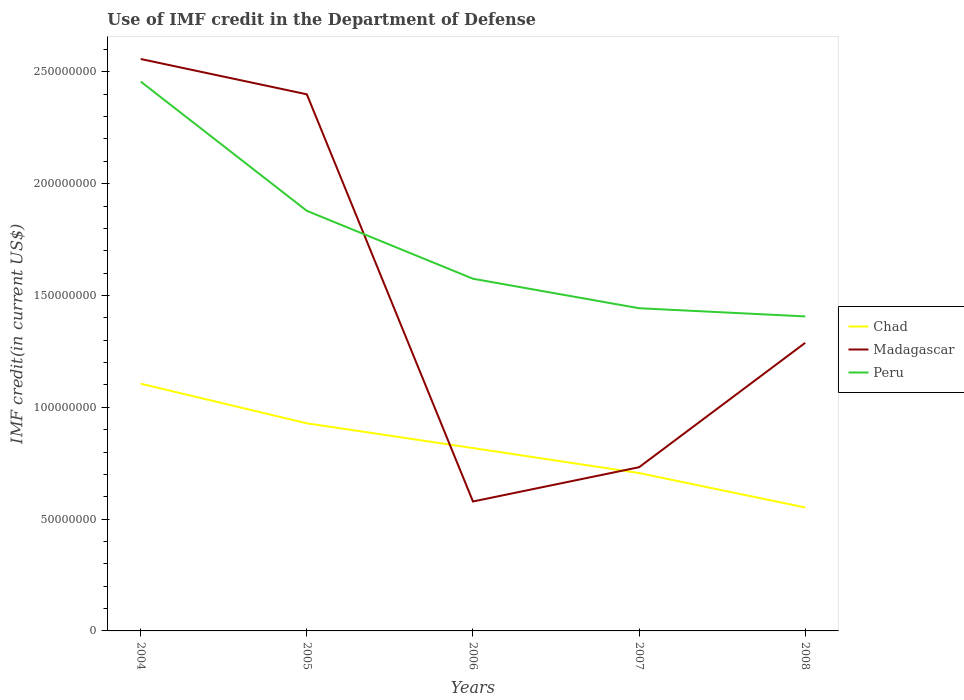How many different coloured lines are there?
Offer a terse response. 3. Does the line corresponding to Madagascar intersect with the line corresponding to Chad?
Give a very brief answer. Yes. Across all years, what is the maximum IMF credit in the Department of Defense in Peru?
Give a very brief answer. 1.41e+08. In which year was the IMF credit in the Department of Defense in Peru maximum?
Provide a succinct answer. 2008. What is the total IMF credit in the Department of Defense in Peru in the graph?
Provide a succinct answer. 1.68e+07. What is the difference between the highest and the second highest IMF credit in the Department of Defense in Peru?
Offer a terse response. 1.05e+08. What is the difference between the highest and the lowest IMF credit in the Department of Defense in Chad?
Offer a terse response. 2. How many lines are there?
Your answer should be very brief. 3. What is the difference between two consecutive major ticks on the Y-axis?
Provide a short and direct response. 5.00e+07. Are the values on the major ticks of Y-axis written in scientific E-notation?
Give a very brief answer. No. Does the graph contain any zero values?
Your answer should be very brief. No. How many legend labels are there?
Your answer should be very brief. 3. What is the title of the graph?
Your answer should be compact. Use of IMF credit in the Department of Defense. What is the label or title of the X-axis?
Give a very brief answer. Years. What is the label or title of the Y-axis?
Your answer should be very brief. IMF credit(in current US$). What is the IMF credit(in current US$) in Chad in 2004?
Your response must be concise. 1.11e+08. What is the IMF credit(in current US$) in Madagascar in 2004?
Keep it short and to the point. 2.56e+08. What is the IMF credit(in current US$) of Peru in 2004?
Offer a terse response. 2.46e+08. What is the IMF credit(in current US$) in Chad in 2005?
Give a very brief answer. 9.28e+07. What is the IMF credit(in current US$) in Madagascar in 2005?
Offer a very short reply. 2.40e+08. What is the IMF credit(in current US$) in Peru in 2005?
Make the answer very short. 1.88e+08. What is the IMF credit(in current US$) in Chad in 2006?
Your answer should be compact. 8.18e+07. What is the IMF credit(in current US$) in Madagascar in 2006?
Offer a very short reply. 5.79e+07. What is the IMF credit(in current US$) in Peru in 2006?
Offer a terse response. 1.58e+08. What is the IMF credit(in current US$) of Chad in 2007?
Your response must be concise. 7.06e+07. What is the IMF credit(in current US$) of Madagascar in 2007?
Provide a succinct answer. 7.32e+07. What is the IMF credit(in current US$) in Peru in 2007?
Keep it short and to the point. 1.44e+08. What is the IMF credit(in current US$) of Chad in 2008?
Make the answer very short. 5.52e+07. What is the IMF credit(in current US$) in Madagascar in 2008?
Offer a terse response. 1.29e+08. What is the IMF credit(in current US$) of Peru in 2008?
Provide a short and direct response. 1.41e+08. Across all years, what is the maximum IMF credit(in current US$) in Chad?
Give a very brief answer. 1.11e+08. Across all years, what is the maximum IMF credit(in current US$) in Madagascar?
Your answer should be very brief. 2.56e+08. Across all years, what is the maximum IMF credit(in current US$) in Peru?
Offer a very short reply. 2.46e+08. Across all years, what is the minimum IMF credit(in current US$) in Chad?
Give a very brief answer. 5.52e+07. Across all years, what is the minimum IMF credit(in current US$) in Madagascar?
Provide a succinct answer. 5.79e+07. Across all years, what is the minimum IMF credit(in current US$) in Peru?
Keep it short and to the point. 1.41e+08. What is the total IMF credit(in current US$) in Chad in the graph?
Provide a succinct answer. 4.11e+08. What is the total IMF credit(in current US$) in Madagascar in the graph?
Your answer should be very brief. 7.56e+08. What is the total IMF credit(in current US$) of Peru in the graph?
Provide a short and direct response. 8.76e+08. What is the difference between the IMF credit(in current US$) in Chad in 2004 and that in 2005?
Ensure brevity in your answer.  1.77e+07. What is the difference between the IMF credit(in current US$) of Madagascar in 2004 and that in 2005?
Offer a terse response. 1.58e+07. What is the difference between the IMF credit(in current US$) of Peru in 2004 and that in 2005?
Provide a succinct answer. 5.78e+07. What is the difference between the IMF credit(in current US$) in Chad in 2004 and that in 2006?
Provide a short and direct response. 2.88e+07. What is the difference between the IMF credit(in current US$) in Madagascar in 2004 and that in 2006?
Provide a succinct answer. 1.98e+08. What is the difference between the IMF credit(in current US$) in Peru in 2004 and that in 2006?
Provide a short and direct response. 8.82e+07. What is the difference between the IMF credit(in current US$) in Chad in 2004 and that in 2007?
Provide a short and direct response. 4.00e+07. What is the difference between the IMF credit(in current US$) in Madagascar in 2004 and that in 2007?
Provide a succinct answer. 1.83e+08. What is the difference between the IMF credit(in current US$) in Peru in 2004 and that in 2007?
Provide a succinct answer. 1.01e+08. What is the difference between the IMF credit(in current US$) of Chad in 2004 and that in 2008?
Your response must be concise. 5.54e+07. What is the difference between the IMF credit(in current US$) of Madagascar in 2004 and that in 2008?
Offer a very short reply. 1.27e+08. What is the difference between the IMF credit(in current US$) of Peru in 2004 and that in 2008?
Your answer should be very brief. 1.05e+08. What is the difference between the IMF credit(in current US$) of Chad in 2005 and that in 2006?
Provide a short and direct response. 1.11e+07. What is the difference between the IMF credit(in current US$) in Madagascar in 2005 and that in 2006?
Offer a very short reply. 1.82e+08. What is the difference between the IMF credit(in current US$) in Peru in 2005 and that in 2006?
Your answer should be compact. 3.04e+07. What is the difference between the IMF credit(in current US$) of Chad in 2005 and that in 2007?
Give a very brief answer. 2.22e+07. What is the difference between the IMF credit(in current US$) in Madagascar in 2005 and that in 2007?
Offer a terse response. 1.67e+08. What is the difference between the IMF credit(in current US$) in Peru in 2005 and that in 2007?
Give a very brief answer. 4.36e+07. What is the difference between the IMF credit(in current US$) of Chad in 2005 and that in 2008?
Offer a terse response. 3.76e+07. What is the difference between the IMF credit(in current US$) of Madagascar in 2005 and that in 2008?
Provide a succinct answer. 1.11e+08. What is the difference between the IMF credit(in current US$) in Peru in 2005 and that in 2008?
Keep it short and to the point. 4.72e+07. What is the difference between the IMF credit(in current US$) in Chad in 2006 and that in 2007?
Give a very brief answer. 1.12e+07. What is the difference between the IMF credit(in current US$) of Madagascar in 2006 and that in 2007?
Your response must be concise. -1.53e+07. What is the difference between the IMF credit(in current US$) of Peru in 2006 and that in 2007?
Provide a succinct answer. 1.32e+07. What is the difference between the IMF credit(in current US$) of Chad in 2006 and that in 2008?
Offer a very short reply. 2.66e+07. What is the difference between the IMF credit(in current US$) in Madagascar in 2006 and that in 2008?
Provide a short and direct response. -7.10e+07. What is the difference between the IMF credit(in current US$) in Peru in 2006 and that in 2008?
Offer a terse response. 1.68e+07. What is the difference between the IMF credit(in current US$) in Chad in 2007 and that in 2008?
Make the answer very short. 1.54e+07. What is the difference between the IMF credit(in current US$) in Madagascar in 2007 and that in 2008?
Ensure brevity in your answer.  -5.56e+07. What is the difference between the IMF credit(in current US$) in Peru in 2007 and that in 2008?
Make the answer very short. 3.65e+06. What is the difference between the IMF credit(in current US$) in Chad in 2004 and the IMF credit(in current US$) in Madagascar in 2005?
Your response must be concise. -1.29e+08. What is the difference between the IMF credit(in current US$) of Chad in 2004 and the IMF credit(in current US$) of Peru in 2005?
Provide a succinct answer. -7.73e+07. What is the difference between the IMF credit(in current US$) of Madagascar in 2004 and the IMF credit(in current US$) of Peru in 2005?
Ensure brevity in your answer.  6.79e+07. What is the difference between the IMF credit(in current US$) in Chad in 2004 and the IMF credit(in current US$) in Madagascar in 2006?
Keep it short and to the point. 5.27e+07. What is the difference between the IMF credit(in current US$) in Chad in 2004 and the IMF credit(in current US$) in Peru in 2006?
Provide a succinct answer. -4.69e+07. What is the difference between the IMF credit(in current US$) in Madagascar in 2004 and the IMF credit(in current US$) in Peru in 2006?
Provide a succinct answer. 9.83e+07. What is the difference between the IMF credit(in current US$) in Chad in 2004 and the IMF credit(in current US$) in Madagascar in 2007?
Your answer should be very brief. 3.73e+07. What is the difference between the IMF credit(in current US$) in Chad in 2004 and the IMF credit(in current US$) in Peru in 2007?
Your answer should be compact. -3.38e+07. What is the difference between the IMF credit(in current US$) of Madagascar in 2004 and the IMF credit(in current US$) of Peru in 2007?
Keep it short and to the point. 1.11e+08. What is the difference between the IMF credit(in current US$) in Chad in 2004 and the IMF credit(in current US$) in Madagascar in 2008?
Your response must be concise. -1.83e+07. What is the difference between the IMF credit(in current US$) in Chad in 2004 and the IMF credit(in current US$) in Peru in 2008?
Your response must be concise. -3.01e+07. What is the difference between the IMF credit(in current US$) of Madagascar in 2004 and the IMF credit(in current US$) of Peru in 2008?
Keep it short and to the point. 1.15e+08. What is the difference between the IMF credit(in current US$) in Chad in 2005 and the IMF credit(in current US$) in Madagascar in 2006?
Your answer should be compact. 3.50e+07. What is the difference between the IMF credit(in current US$) in Chad in 2005 and the IMF credit(in current US$) in Peru in 2006?
Your answer should be compact. -6.47e+07. What is the difference between the IMF credit(in current US$) in Madagascar in 2005 and the IMF credit(in current US$) in Peru in 2006?
Make the answer very short. 8.25e+07. What is the difference between the IMF credit(in current US$) of Chad in 2005 and the IMF credit(in current US$) of Madagascar in 2007?
Your response must be concise. 1.96e+07. What is the difference between the IMF credit(in current US$) in Chad in 2005 and the IMF credit(in current US$) in Peru in 2007?
Offer a very short reply. -5.15e+07. What is the difference between the IMF credit(in current US$) in Madagascar in 2005 and the IMF credit(in current US$) in Peru in 2007?
Your answer should be compact. 9.57e+07. What is the difference between the IMF credit(in current US$) in Chad in 2005 and the IMF credit(in current US$) in Madagascar in 2008?
Offer a very short reply. -3.60e+07. What is the difference between the IMF credit(in current US$) in Chad in 2005 and the IMF credit(in current US$) in Peru in 2008?
Offer a very short reply. -4.78e+07. What is the difference between the IMF credit(in current US$) of Madagascar in 2005 and the IMF credit(in current US$) of Peru in 2008?
Offer a very short reply. 9.93e+07. What is the difference between the IMF credit(in current US$) of Chad in 2006 and the IMF credit(in current US$) of Madagascar in 2007?
Provide a succinct answer. 8.57e+06. What is the difference between the IMF credit(in current US$) of Chad in 2006 and the IMF credit(in current US$) of Peru in 2007?
Give a very brief answer. -6.25e+07. What is the difference between the IMF credit(in current US$) of Madagascar in 2006 and the IMF credit(in current US$) of Peru in 2007?
Offer a terse response. -8.64e+07. What is the difference between the IMF credit(in current US$) in Chad in 2006 and the IMF credit(in current US$) in Madagascar in 2008?
Ensure brevity in your answer.  -4.71e+07. What is the difference between the IMF credit(in current US$) in Chad in 2006 and the IMF credit(in current US$) in Peru in 2008?
Give a very brief answer. -5.89e+07. What is the difference between the IMF credit(in current US$) in Madagascar in 2006 and the IMF credit(in current US$) in Peru in 2008?
Your response must be concise. -8.28e+07. What is the difference between the IMF credit(in current US$) in Chad in 2007 and the IMF credit(in current US$) in Madagascar in 2008?
Keep it short and to the point. -5.82e+07. What is the difference between the IMF credit(in current US$) of Chad in 2007 and the IMF credit(in current US$) of Peru in 2008?
Provide a short and direct response. -7.01e+07. What is the difference between the IMF credit(in current US$) of Madagascar in 2007 and the IMF credit(in current US$) of Peru in 2008?
Your response must be concise. -6.74e+07. What is the average IMF credit(in current US$) of Chad per year?
Provide a short and direct response. 8.22e+07. What is the average IMF credit(in current US$) in Madagascar per year?
Give a very brief answer. 1.51e+08. What is the average IMF credit(in current US$) in Peru per year?
Offer a very short reply. 1.75e+08. In the year 2004, what is the difference between the IMF credit(in current US$) of Chad and IMF credit(in current US$) of Madagascar?
Keep it short and to the point. -1.45e+08. In the year 2004, what is the difference between the IMF credit(in current US$) of Chad and IMF credit(in current US$) of Peru?
Your answer should be very brief. -1.35e+08. In the year 2004, what is the difference between the IMF credit(in current US$) in Madagascar and IMF credit(in current US$) in Peru?
Offer a terse response. 1.01e+07. In the year 2005, what is the difference between the IMF credit(in current US$) of Chad and IMF credit(in current US$) of Madagascar?
Keep it short and to the point. -1.47e+08. In the year 2005, what is the difference between the IMF credit(in current US$) of Chad and IMF credit(in current US$) of Peru?
Ensure brevity in your answer.  -9.50e+07. In the year 2005, what is the difference between the IMF credit(in current US$) of Madagascar and IMF credit(in current US$) of Peru?
Make the answer very short. 5.21e+07. In the year 2006, what is the difference between the IMF credit(in current US$) in Chad and IMF credit(in current US$) in Madagascar?
Provide a succinct answer. 2.39e+07. In the year 2006, what is the difference between the IMF credit(in current US$) of Chad and IMF credit(in current US$) of Peru?
Make the answer very short. -7.57e+07. In the year 2006, what is the difference between the IMF credit(in current US$) of Madagascar and IMF credit(in current US$) of Peru?
Give a very brief answer. -9.96e+07. In the year 2007, what is the difference between the IMF credit(in current US$) of Chad and IMF credit(in current US$) of Madagascar?
Provide a succinct answer. -2.62e+06. In the year 2007, what is the difference between the IMF credit(in current US$) in Chad and IMF credit(in current US$) in Peru?
Your response must be concise. -7.37e+07. In the year 2007, what is the difference between the IMF credit(in current US$) in Madagascar and IMF credit(in current US$) in Peru?
Make the answer very short. -7.11e+07. In the year 2008, what is the difference between the IMF credit(in current US$) in Chad and IMF credit(in current US$) in Madagascar?
Keep it short and to the point. -7.36e+07. In the year 2008, what is the difference between the IMF credit(in current US$) in Chad and IMF credit(in current US$) in Peru?
Give a very brief answer. -8.55e+07. In the year 2008, what is the difference between the IMF credit(in current US$) of Madagascar and IMF credit(in current US$) of Peru?
Offer a terse response. -1.18e+07. What is the ratio of the IMF credit(in current US$) in Chad in 2004 to that in 2005?
Ensure brevity in your answer.  1.19. What is the ratio of the IMF credit(in current US$) of Madagascar in 2004 to that in 2005?
Your response must be concise. 1.07. What is the ratio of the IMF credit(in current US$) in Peru in 2004 to that in 2005?
Make the answer very short. 1.31. What is the ratio of the IMF credit(in current US$) of Chad in 2004 to that in 2006?
Your answer should be compact. 1.35. What is the ratio of the IMF credit(in current US$) in Madagascar in 2004 to that in 2006?
Your response must be concise. 4.42. What is the ratio of the IMF credit(in current US$) in Peru in 2004 to that in 2006?
Offer a terse response. 1.56. What is the ratio of the IMF credit(in current US$) in Chad in 2004 to that in 2007?
Your answer should be compact. 1.57. What is the ratio of the IMF credit(in current US$) of Madagascar in 2004 to that in 2007?
Ensure brevity in your answer.  3.49. What is the ratio of the IMF credit(in current US$) of Peru in 2004 to that in 2007?
Offer a terse response. 1.7. What is the ratio of the IMF credit(in current US$) in Chad in 2004 to that in 2008?
Your answer should be compact. 2. What is the ratio of the IMF credit(in current US$) in Madagascar in 2004 to that in 2008?
Make the answer very short. 1.99. What is the ratio of the IMF credit(in current US$) of Peru in 2004 to that in 2008?
Offer a terse response. 1.75. What is the ratio of the IMF credit(in current US$) in Chad in 2005 to that in 2006?
Your answer should be very brief. 1.14. What is the ratio of the IMF credit(in current US$) in Madagascar in 2005 to that in 2006?
Provide a short and direct response. 4.15. What is the ratio of the IMF credit(in current US$) of Peru in 2005 to that in 2006?
Offer a very short reply. 1.19. What is the ratio of the IMF credit(in current US$) in Chad in 2005 to that in 2007?
Make the answer very short. 1.32. What is the ratio of the IMF credit(in current US$) of Madagascar in 2005 to that in 2007?
Give a very brief answer. 3.28. What is the ratio of the IMF credit(in current US$) of Peru in 2005 to that in 2007?
Make the answer very short. 1.3. What is the ratio of the IMF credit(in current US$) in Chad in 2005 to that in 2008?
Offer a terse response. 1.68. What is the ratio of the IMF credit(in current US$) in Madagascar in 2005 to that in 2008?
Provide a succinct answer. 1.86. What is the ratio of the IMF credit(in current US$) in Peru in 2005 to that in 2008?
Offer a terse response. 1.34. What is the ratio of the IMF credit(in current US$) in Chad in 2006 to that in 2007?
Offer a very short reply. 1.16. What is the ratio of the IMF credit(in current US$) of Madagascar in 2006 to that in 2007?
Give a very brief answer. 0.79. What is the ratio of the IMF credit(in current US$) of Peru in 2006 to that in 2007?
Your answer should be very brief. 1.09. What is the ratio of the IMF credit(in current US$) of Chad in 2006 to that in 2008?
Your answer should be very brief. 1.48. What is the ratio of the IMF credit(in current US$) of Madagascar in 2006 to that in 2008?
Provide a succinct answer. 0.45. What is the ratio of the IMF credit(in current US$) in Peru in 2006 to that in 2008?
Offer a very short reply. 1.12. What is the ratio of the IMF credit(in current US$) of Chad in 2007 to that in 2008?
Provide a succinct answer. 1.28. What is the ratio of the IMF credit(in current US$) in Madagascar in 2007 to that in 2008?
Offer a very short reply. 0.57. What is the ratio of the IMF credit(in current US$) of Peru in 2007 to that in 2008?
Offer a terse response. 1.03. What is the difference between the highest and the second highest IMF credit(in current US$) of Chad?
Your answer should be compact. 1.77e+07. What is the difference between the highest and the second highest IMF credit(in current US$) in Madagascar?
Your response must be concise. 1.58e+07. What is the difference between the highest and the second highest IMF credit(in current US$) of Peru?
Your answer should be compact. 5.78e+07. What is the difference between the highest and the lowest IMF credit(in current US$) in Chad?
Keep it short and to the point. 5.54e+07. What is the difference between the highest and the lowest IMF credit(in current US$) in Madagascar?
Your answer should be very brief. 1.98e+08. What is the difference between the highest and the lowest IMF credit(in current US$) in Peru?
Offer a very short reply. 1.05e+08. 